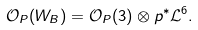<formula> <loc_0><loc_0><loc_500><loc_500>{ \mathcal { O } } _ { P } ( W _ { B } ) = { \mathcal { O } } _ { P } ( 3 ) \otimes p ^ { * } { \mathcal { L } } ^ { 6 } .</formula> 